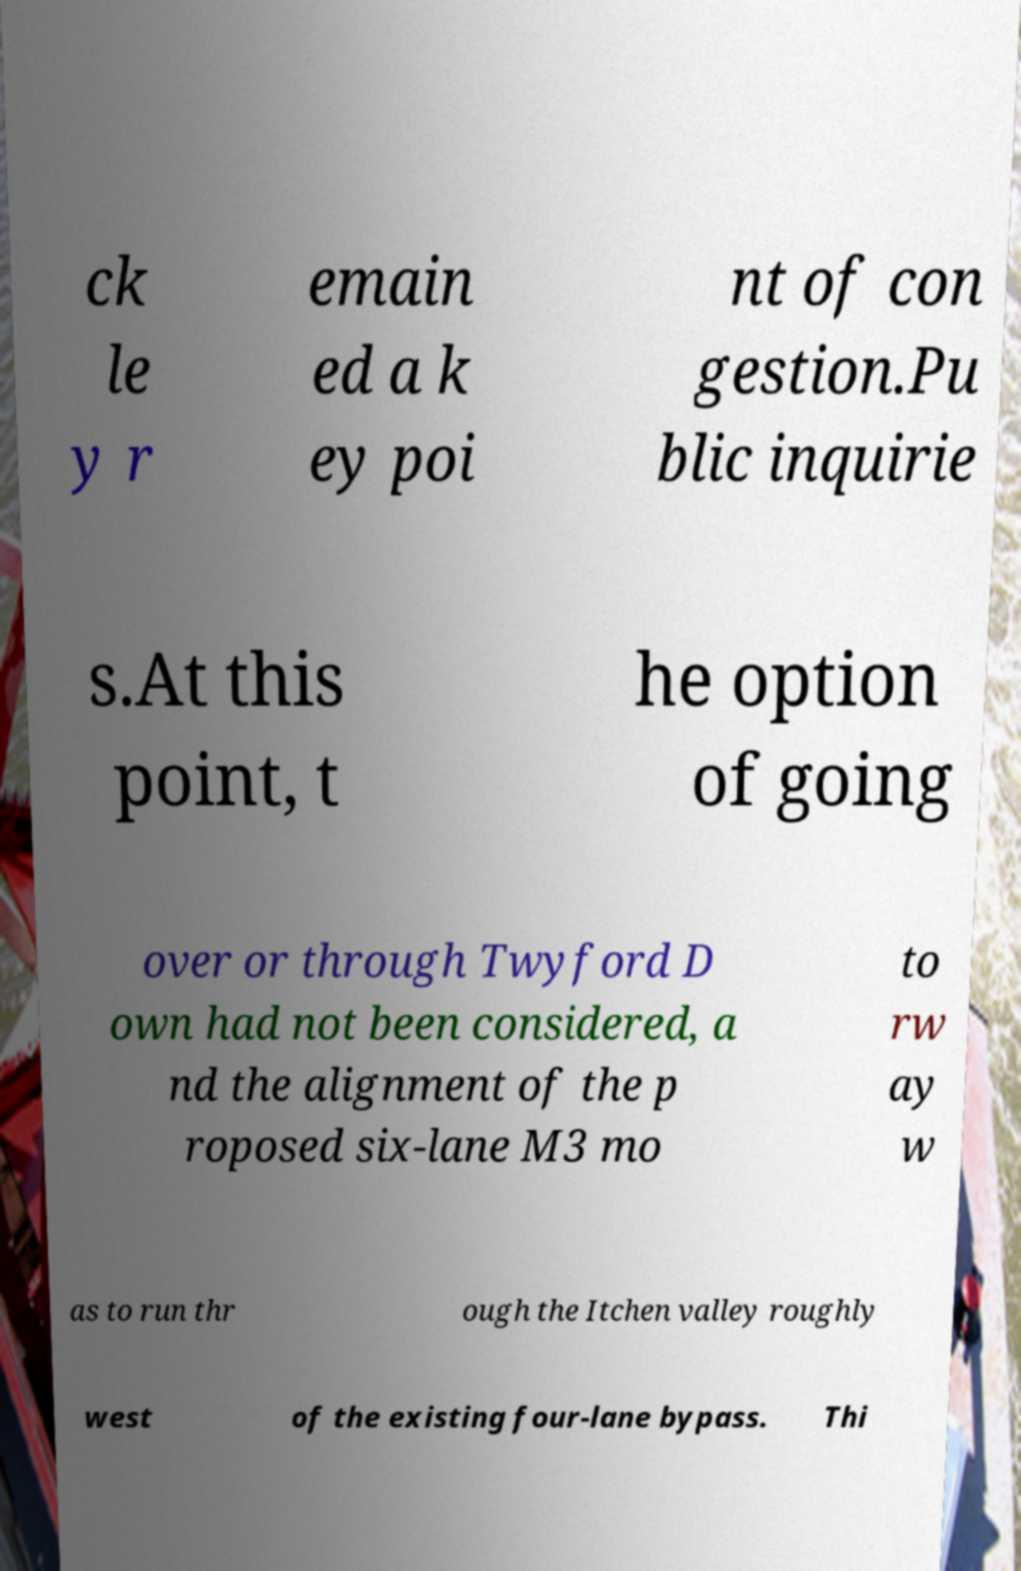I need the written content from this picture converted into text. Can you do that? ck le y r emain ed a k ey poi nt of con gestion.Pu blic inquirie s.At this point, t he option of going over or through Twyford D own had not been considered, a nd the alignment of the p roposed six-lane M3 mo to rw ay w as to run thr ough the Itchen valley roughly west of the existing four-lane bypass. Thi 